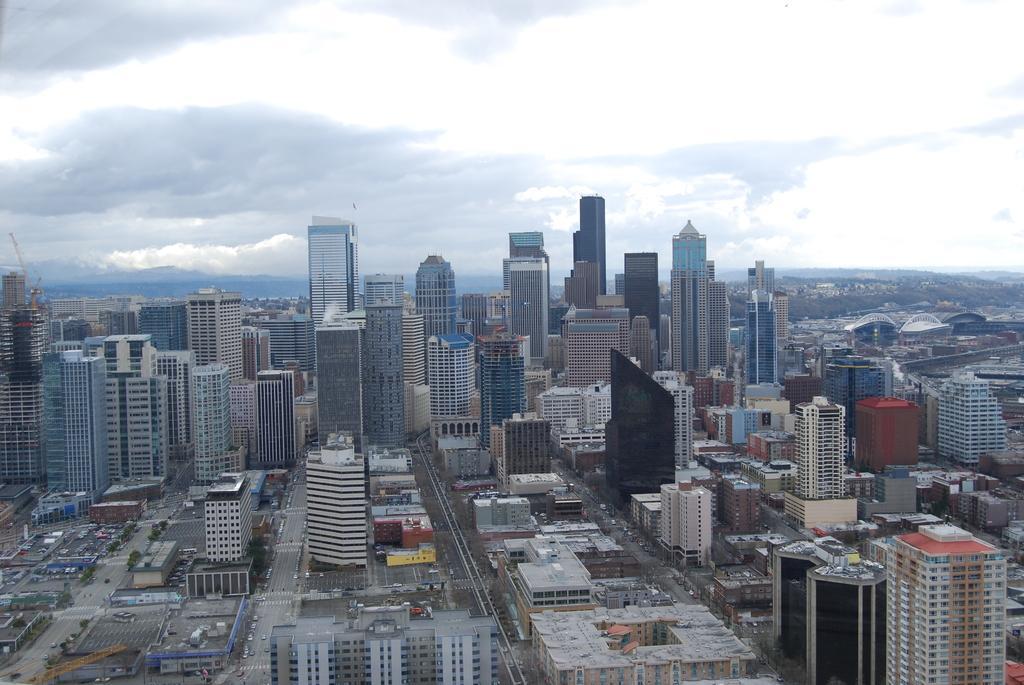Can you describe this image briefly? In this picture we can see buildings, roads, vehicles, trees and in the background we can see the sky with clouds. 